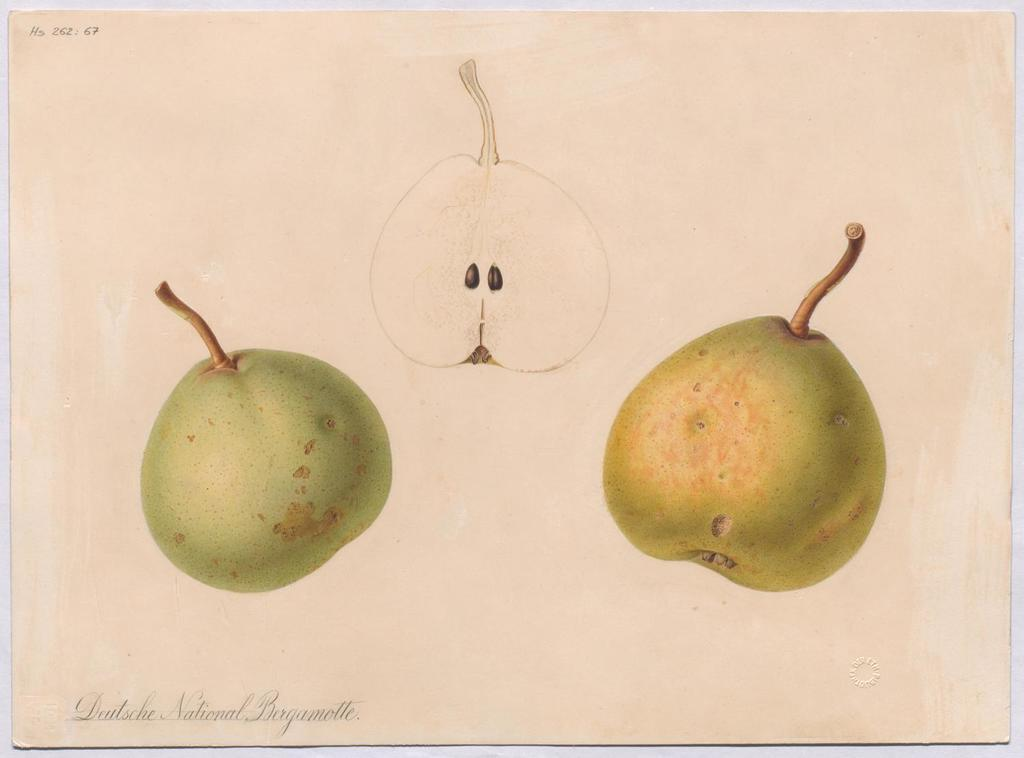What type of artwork is depicted in the image? There are paintings of fruits in the image. How many letters are hidden in the paintings of fruits in the image? There are no letters hidden in the paintings of fruits in the image. Are there any babies depicted in the paintings of fruits in the image? There are no babies depicted in the paintings of fruits in the image. Is there a spy present in the paintings of fruits in the image? There are no spies depicted in the paintings of fruits in the image. 